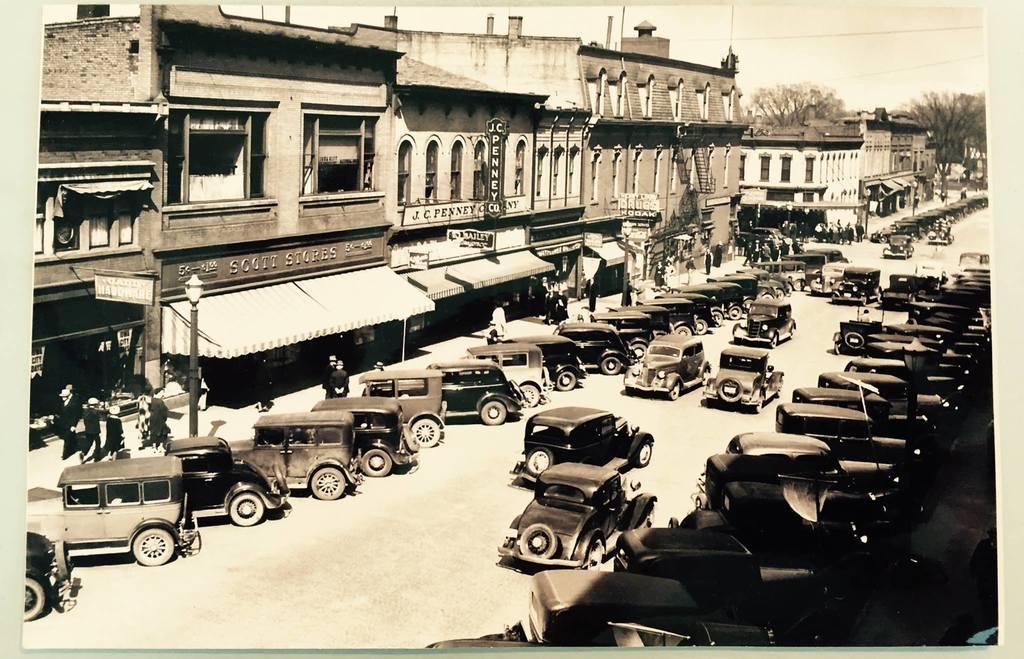Please provide a concise description of this image. This picture is an edited picture. In this image there are vehicles on the road. There are group of people walking on the footpath. At the back there are buildings and there are poles and trees on the footpath. At the top there is sky and there are wires. At the bottom there is a road. 